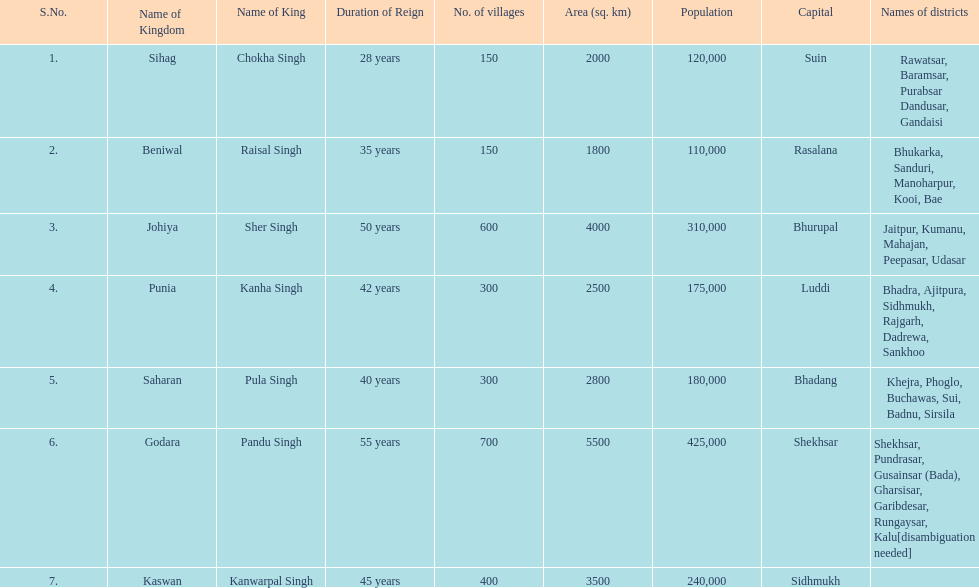Who was the ruler of the sihag kingdom? Chokha Singh. 